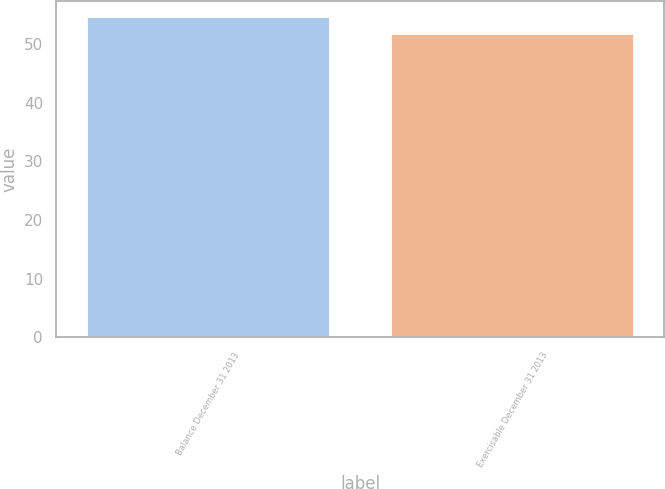Convert chart to OTSL. <chart><loc_0><loc_0><loc_500><loc_500><bar_chart><fcel>Balance December 31 2013<fcel>Exercisable December 31 2013<nl><fcel>54.7<fcel>51.78<nl></chart> 